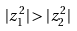Convert formula to latex. <formula><loc_0><loc_0><loc_500><loc_500>| z _ { 1 } ^ { 2 } | > | z _ { 2 } ^ { 2 } |</formula> 